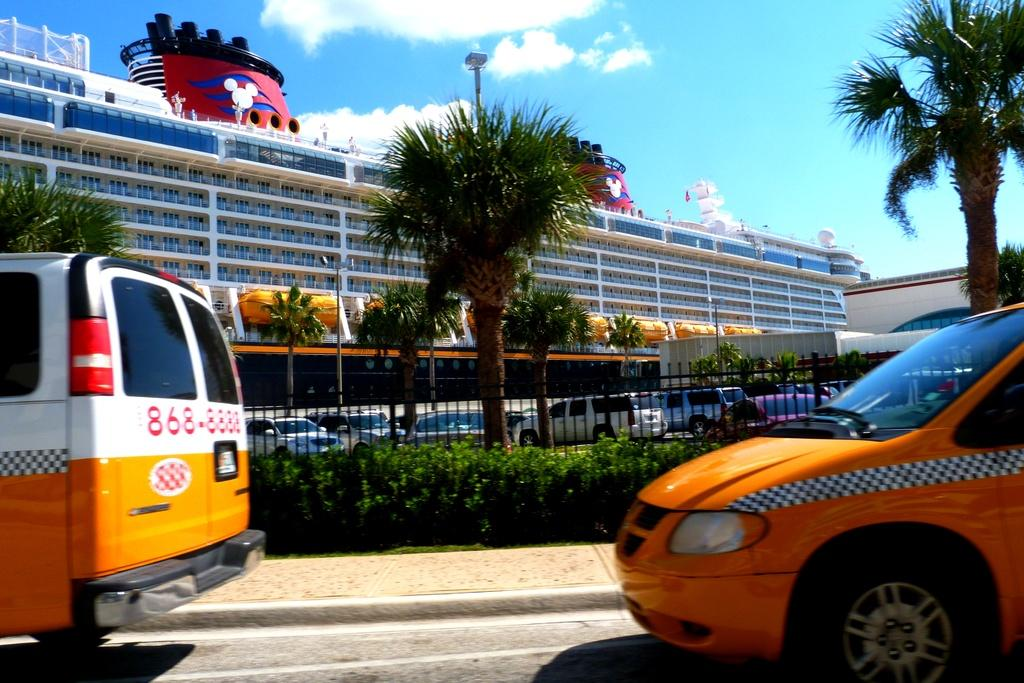<image>
Render a clear and concise summary of the photo. A van used as a taxi has a phone number written on it, it is 868-8888. 